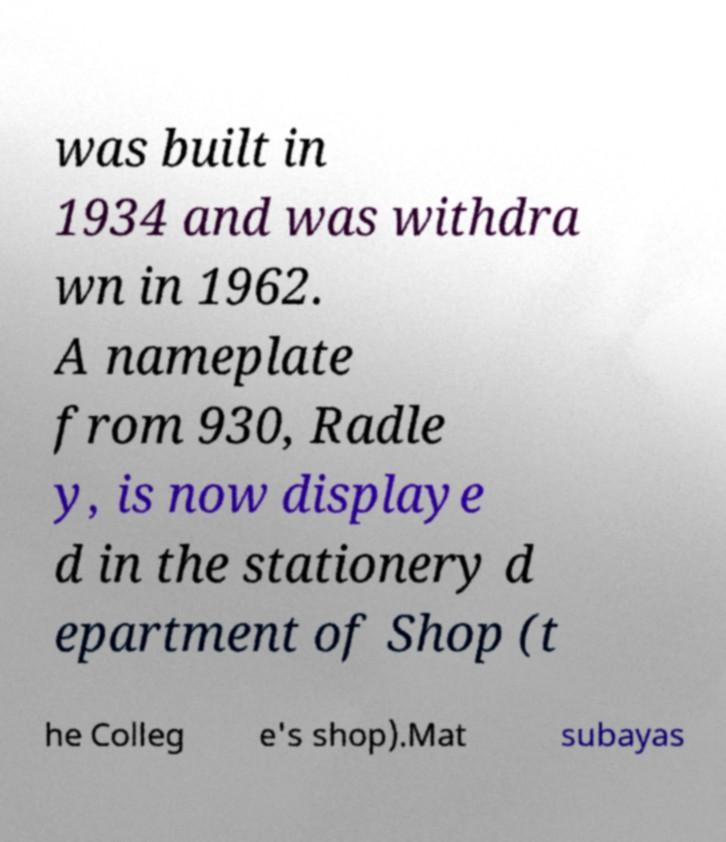Could you assist in decoding the text presented in this image and type it out clearly? was built in 1934 and was withdra wn in 1962. A nameplate from 930, Radle y, is now displaye d in the stationery d epartment of Shop (t he Colleg e's shop).Mat subayas 